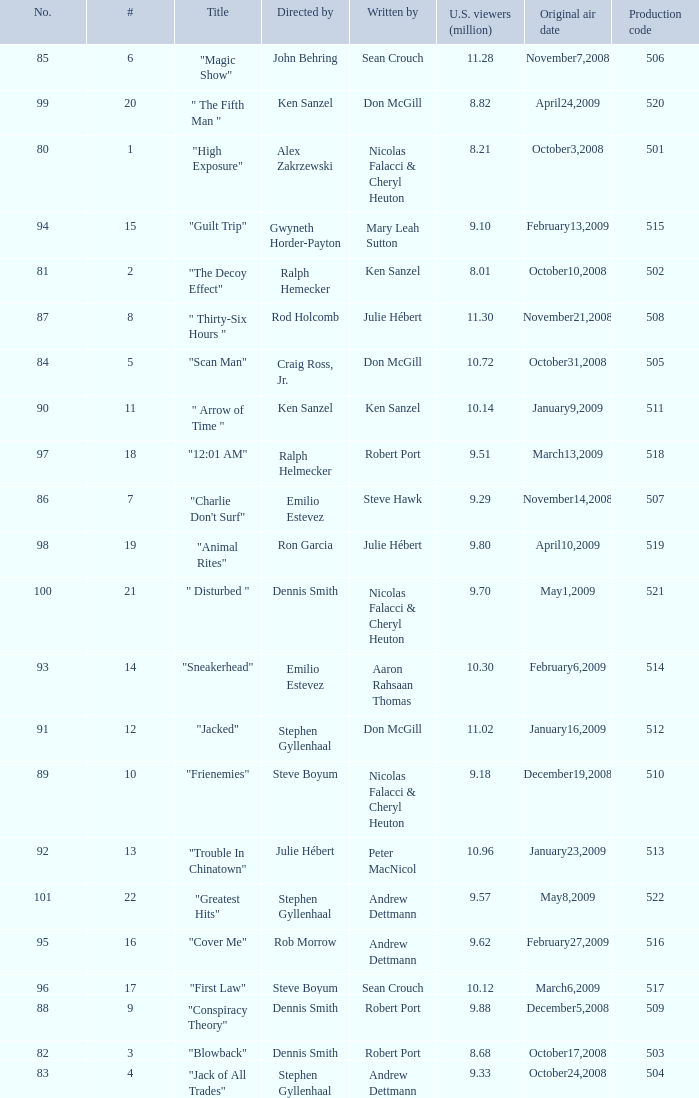What episode had 10.14 million viewers (U.S.)? 11.0. Can you give me this table as a dict? {'header': ['No.', '#', 'Title', 'Directed by', 'Written by', 'U.S. viewers (million)', 'Original air date', 'Production code'], 'rows': [['85', '6', '"Magic Show"', 'John Behring', 'Sean Crouch', '11.28', 'November7,2008', '506'], ['99', '20', '" The Fifth Man "', 'Ken Sanzel', 'Don McGill', '8.82', 'April24,2009', '520'], ['80', '1', '"High Exposure"', 'Alex Zakrzewski', 'Nicolas Falacci & Cheryl Heuton', '8.21', 'October3,2008', '501'], ['94', '15', '"Guilt Trip"', 'Gwyneth Horder-Payton', 'Mary Leah Sutton', '9.10', 'February13,2009', '515'], ['81', '2', '"The Decoy Effect"', 'Ralph Hemecker', 'Ken Sanzel', '8.01', 'October10,2008', '502'], ['87', '8', '" Thirty-Six Hours "', 'Rod Holcomb', 'Julie Hébert', '11.30', 'November21,2008', '508'], ['84', '5', '"Scan Man"', 'Craig Ross, Jr.', 'Don McGill', '10.72', 'October31,2008', '505'], ['90', '11', '" Arrow of Time "', 'Ken Sanzel', 'Ken Sanzel', '10.14', 'January9,2009', '511'], ['97', '18', '"12:01 AM"', 'Ralph Helmecker', 'Robert Port', '9.51', 'March13,2009', '518'], ['86', '7', '"Charlie Don\'t Surf"', 'Emilio Estevez', 'Steve Hawk', '9.29', 'November14,2008', '507'], ['98', '19', '"Animal Rites"', 'Ron Garcia', 'Julie Hébert', '9.80', 'April10,2009', '519'], ['100', '21', '" Disturbed "', 'Dennis Smith', 'Nicolas Falacci & Cheryl Heuton', '9.70', 'May1,2009', '521'], ['93', '14', '"Sneakerhead"', 'Emilio Estevez', 'Aaron Rahsaan Thomas', '10.30', 'February6,2009', '514'], ['91', '12', '"Jacked"', 'Stephen Gyllenhaal', 'Don McGill', '11.02', 'January16,2009', '512'], ['89', '10', '"Frienemies"', 'Steve Boyum', 'Nicolas Falacci & Cheryl Heuton', '9.18', 'December19,2008', '510'], ['92', '13', '"Trouble In Chinatown"', 'Julie Hébert', 'Peter MacNicol', '10.96', 'January23,2009', '513'], ['101', '22', '"Greatest Hits"', 'Stephen Gyllenhaal', 'Andrew Dettmann', '9.57', 'May8,2009', '522'], ['95', '16', '"Cover Me"', 'Rob Morrow', 'Andrew Dettmann', '9.62', 'February27,2009', '516'], ['96', '17', '"First Law"', 'Steve Boyum', 'Sean Crouch', '10.12', 'March6,2009', '517'], ['88', '9', '"Conspiracy Theory"', 'Dennis Smith', 'Robert Port', '9.88', 'December5,2008', '509'], ['82', '3', '"Blowback"', 'Dennis Smith', 'Robert Port', '8.68', 'October17,2008', '503'], ['83', '4', '"Jack of All Trades"', 'Stephen Gyllenhaal', 'Andrew Dettmann', '9.33', 'October24,2008', '504']]} 